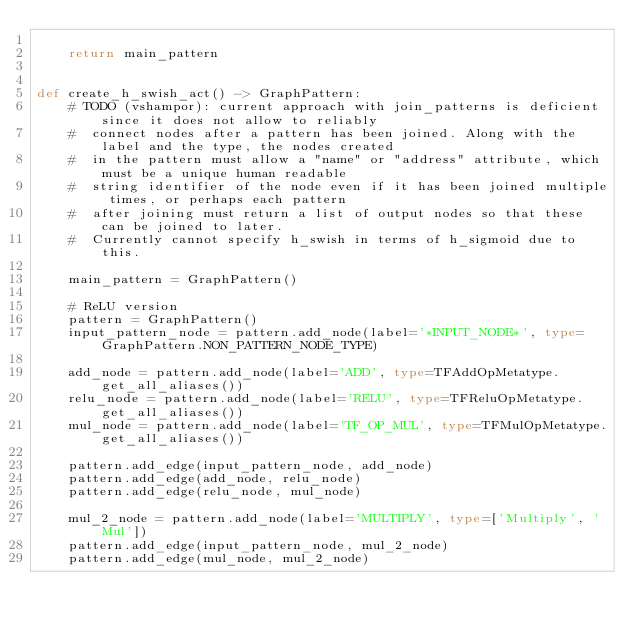<code> <loc_0><loc_0><loc_500><loc_500><_Python_>
    return main_pattern


def create_h_swish_act() -> GraphPattern:
    # TODO (vshampor): current approach with join_patterns is deficient since it does not allow to reliably
    #  connect nodes after a pattern has been joined. Along with the label and the type, the nodes created
    #  in the pattern must allow a "name" or "address" attribute, which must be a unique human readable
    #  string identifier of the node even if it has been joined multiple times, or perhaps each pattern
    #  after joining must return a list of output nodes so that these can be joined to later.
    #  Currently cannot specify h_swish in terms of h_sigmoid due to this.

    main_pattern = GraphPattern()

    # ReLU version
    pattern = GraphPattern()
    input_pattern_node = pattern.add_node(label='*INPUT_NODE*', type=GraphPattern.NON_PATTERN_NODE_TYPE)

    add_node = pattern.add_node(label='ADD', type=TFAddOpMetatype.get_all_aliases())
    relu_node = pattern.add_node(label='RELU', type=TFReluOpMetatype.get_all_aliases())
    mul_node = pattern.add_node(label='TF_OP_MUL', type=TFMulOpMetatype.get_all_aliases())

    pattern.add_edge(input_pattern_node, add_node)
    pattern.add_edge(add_node, relu_node)
    pattern.add_edge(relu_node, mul_node)

    mul_2_node = pattern.add_node(label='MULTIPLY', type=['Multiply', 'Mul'])
    pattern.add_edge(input_pattern_node, mul_2_node)
    pattern.add_edge(mul_node, mul_2_node)</code> 